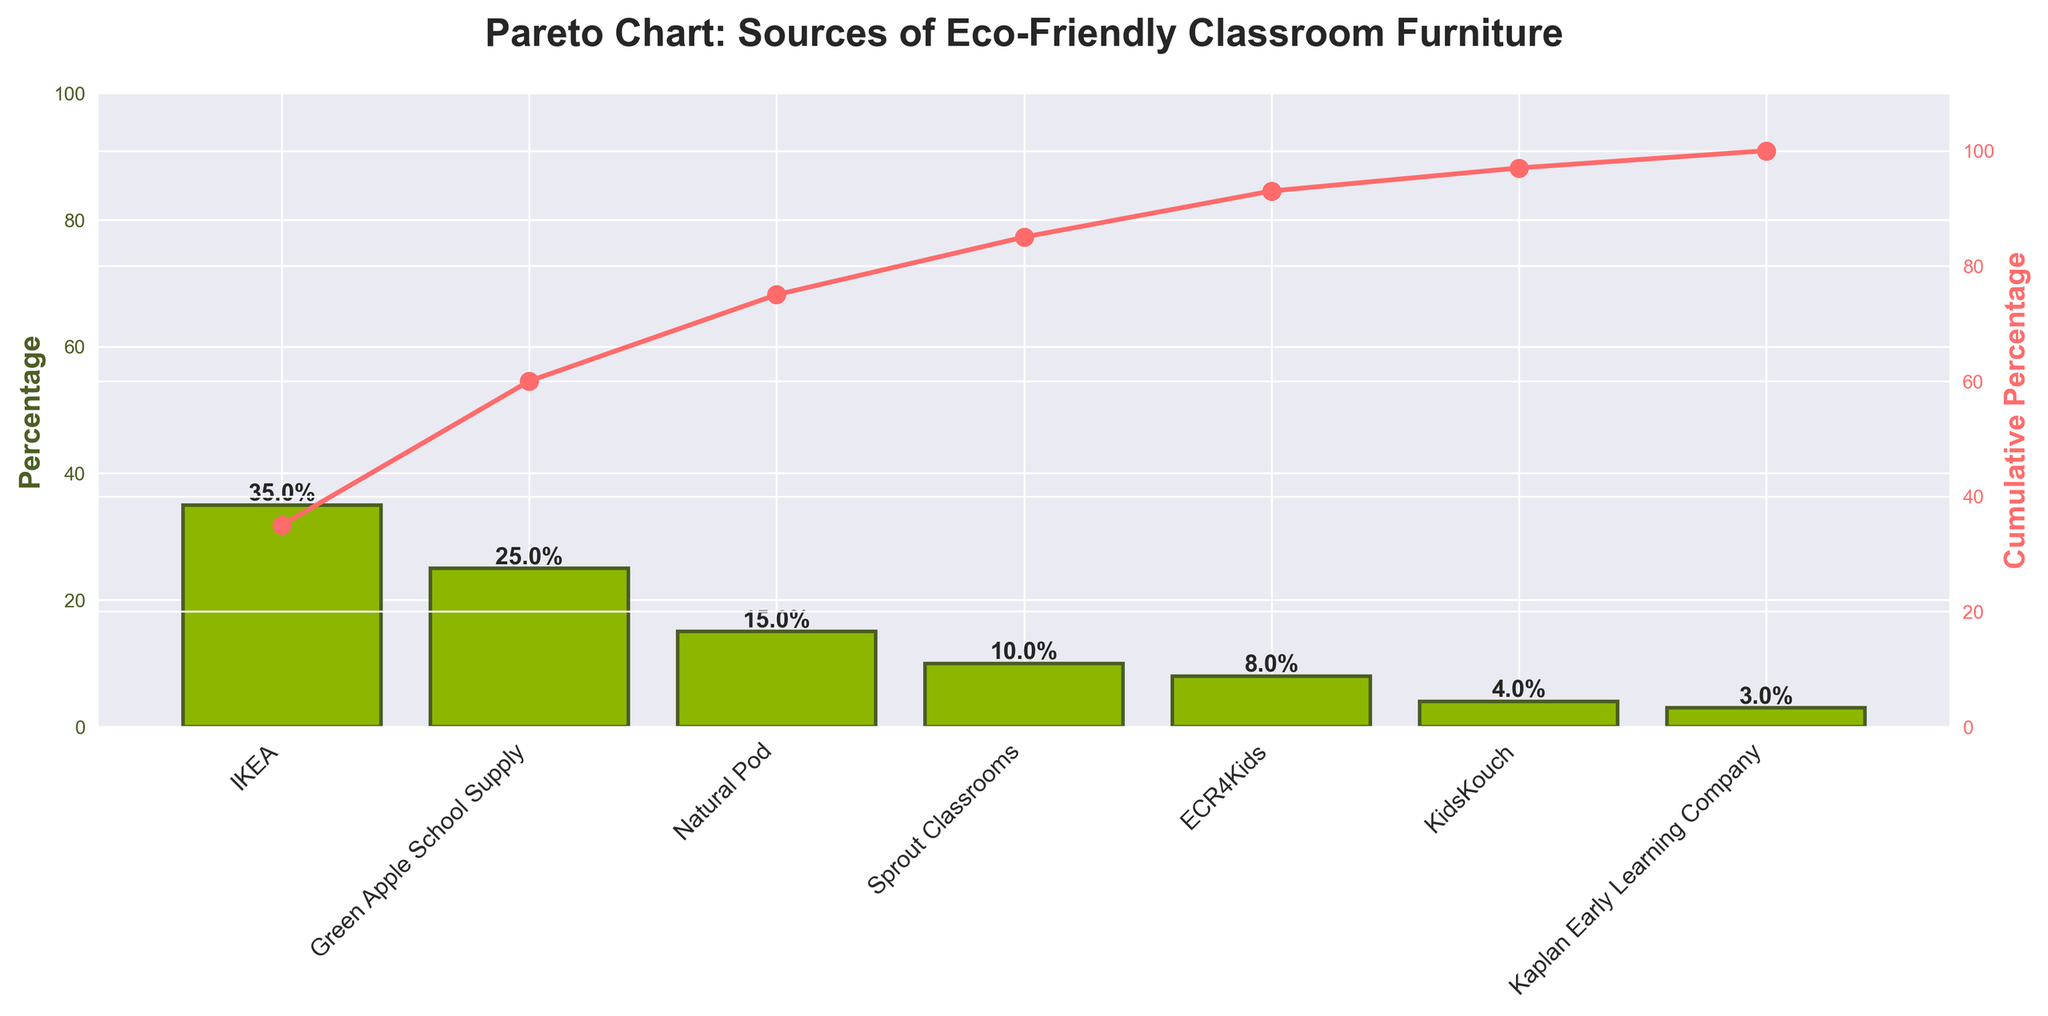What's the title of the plot? The title of the plot is displayed at the top and provides a brief description of what the chart is about. In this case, the title is "Pareto Chart: Sources of Eco-Friendly Classroom Furniture".
Answer: Pareto Chart: Sources of Eco-Friendly Classroom Furniture Which source contributes the most to eco-friendly classroom furniture? The highest bar in the bar chart usually indicates the largest contributor. Here, the bar for IKEA is the tallest, indicating it as the top source.
Answer: IKEA What's the combined percentage of the top three sources? To find the combined percentage, add the percentages of the top three sources: IKEA (35%), Green Apple School Supply (25%), and Natural Pod (15%). The sum is 35 + 25 + 15 = 75%.
Answer: 75% At what percentage does the cumulative percentage line reach its peak? The cumulative percentage line reaches its peak at the end of the categories, which corresponds to ECR4Kids, KidsKouch, and Kaplan Early Learning Company. The peak value is 100%, as indicated on the y-axis of the cumulative percentage scale.
Answer: 100% How many sources are listed in the chart? Count the number of distinct bars (or categories) along the x-axis. The chart lists sources such as IKEA, Green Apple School Supply, Natural Pod, Sprout Classrooms, ECR4Kids, KidsKouch, and Kaplan Early Learning Company, totaling 7 sources.
Answer: 7 What percentage of eco-friendly furniture does Kaplan Early Learning Company provide? The bar for Kaplan Early Learning Company is the shortest and has a label indicating its value. According to the chart, this percentage is 3%.
Answer: 3% Is Natural Pod's contribution greater or smaller than Sprout Classrooms? Compare the heights of the bars for Natural Pod and Sprout Classrooms. Natural Pod's bar is higher, corresponding to 15%, while Sprout Classrooms' bar is lower, corresponding to 10%.
Answer: Greater What's the cumulative percentage after the top four sources? Look at the cumulative percentage line value after the fourth source. The top four contributors are IKEA, Green Apple School Supply, Natural Pod, and Sprout Classrooms with percentages 35%, 25%, 15%, and 10% respectively. Their cumulative percentage is 35 + 25 + 15 + 10 = 85%.
Answer: 85% If IKEA's percentage was reduced by 5%, would it still be the highest contributing source? After reducing IKEA's percentage by 5%, its new percentage would be 35% - 5% = 30%. With Green Apple School Supply at 25%, IKEA would still be the highest contributing source with 30%.
Answer: Yes Which source provides the least percentage of eco-friendly classroom furniture? The shortest bar on the chart indicates the least contributing source. The chart shows that Kaplan Early Learning Company provides the least with 3%.
Answer: Kaplan Early Learning Company 